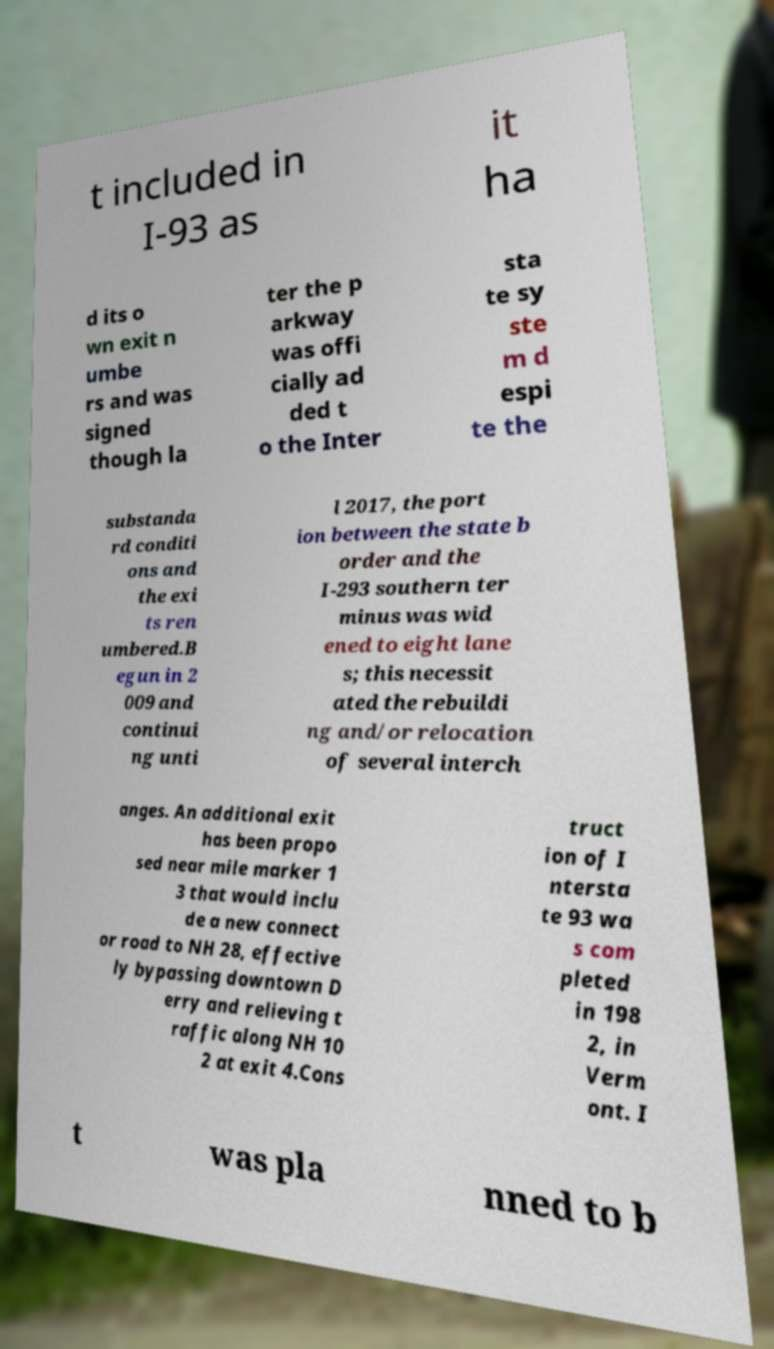For documentation purposes, I need the text within this image transcribed. Could you provide that? t included in I-93 as it ha d its o wn exit n umbe rs and was signed though la ter the p arkway was offi cially ad ded t o the Inter sta te sy ste m d espi te the substanda rd conditi ons and the exi ts ren umbered.B egun in 2 009 and continui ng unti l 2017, the port ion between the state b order and the I-293 southern ter minus was wid ened to eight lane s; this necessit ated the rebuildi ng and/or relocation of several interch anges. An additional exit has been propo sed near mile marker 1 3 that would inclu de a new connect or road to NH 28, effective ly bypassing downtown D erry and relieving t raffic along NH 10 2 at exit 4.Cons truct ion of I ntersta te 93 wa s com pleted in 198 2, in Verm ont. I t was pla nned to b 